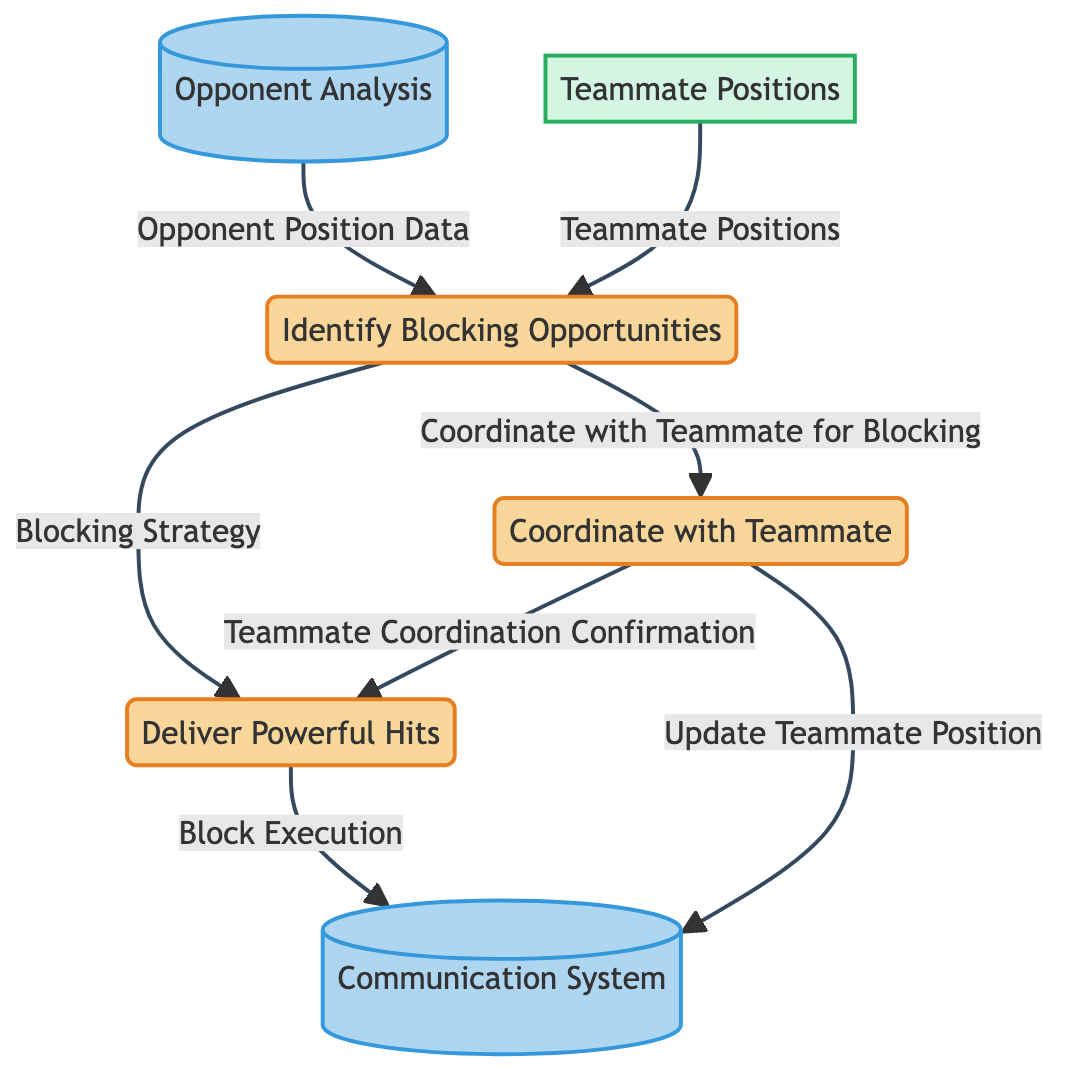What is the first process in the diagram? The first process listed in the diagram is "Identify Blocking Opportunities." This can be determined by looking at the processes section and identifying the one with the lowest ID, which is process 1.
Answer: Identify Blocking Opportunities How many processes are in the diagram? The diagram contains three processes: "Identify Blocking Opportunities," "Deliver Powerful Hits," and "Coordinate with Teammate." By counting the entries under the processes section, we arrive at the total count.
Answer: 3 What data flows from "Identify Blocking Opportunities" to "Deliver Powerful Hits"? The data that flows from "Identify Blocking Opportunities" to "Deliver Powerful Hits" is "Blocking Strategy." This relationship is established by examining the connections between the nodes in the diagram.
Answer: Blocking Strategy Which datastore stores the output of "Deliver Powerful Hits"? The output of "Deliver Powerful Hits," which is "Block Execution," is stored in the "Communication System." This can be confirmed by checking the output flow that leads to the datastore from the process.
Answer: Communication System What is the last process in the diagram? The last process listed in the diagram is "Coordinate with Teammate." This is determined by looking for the process that is last in the listed order.
Answer: Coordinate with Teammate What is the input for "Coordinate with Teammate"? The input for the process "Coordinate with Teammate" is "Blocking Strategy." This can be found by tracking the inputs required for this specific process as indicated in the data flow diagram.
Answer: Blocking Strategy How many data flows are associated with "Coordinate with Teammate"? There are three data flows associated with "Coordinate with Teammate": it receives "Coordinate with Teammate for Blocking" and sends out "Teammate Coordination Confirmation" and "Update Teammate Position." By counting these connections, we find the answer.
Answer: 3 What type of data does "Communication System" store? The "Communication System" stores information about team communication during the match, including "Update Teammate Position" and "Block Execution." This information is gathered by analyzing the outputs directed toward this datastore.
Answer: Team communication information What role do "Teammate Positions" play in this diagram? "Teammate Positions" serve as an external input to the process "Identify Blocking Opportunities," providing necessary data about current teammate locations. This is evident from the external entities section and its connection to the respective process.
Answer: External input 